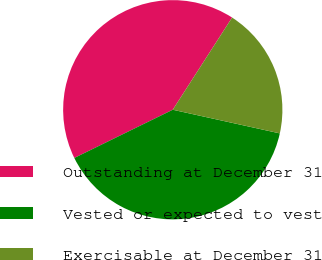<chart> <loc_0><loc_0><loc_500><loc_500><pie_chart><fcel>Outstanding at December 31<fcel>Vested or expected to vest<fcel>Exercisable at December 31<nl><fcel>41.35%<fcel>39.29%<fcel>19.36%<nl></chart> 